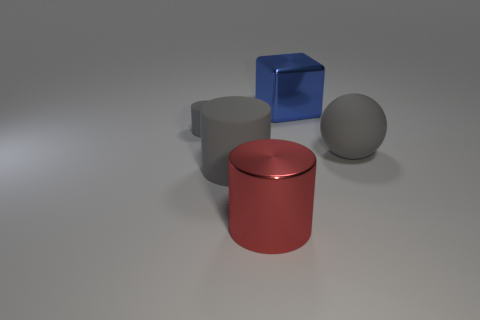What material do the objects in the image appear to be made from? The objects exhibit characteristics of various materials. The sphere and the cylindrical shapes present a matte finish suggestive of a non-glossy rubber or plastic, while the cube in the back has a shiny blue surface, indicating a more reflective material like glass or polished metal. 